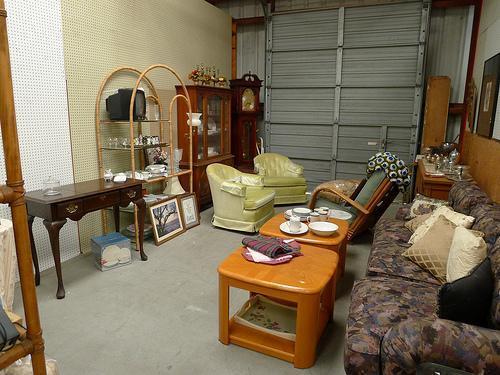How many chairs are seen?
Give a very brief answer. 3. How many couches are visible?
Give a very brief answer. 1. How many rectangular panels make up the metal door?
Give a very brief answer. 10. How many colors is the wall to the left?
Give a very brief answer. 2. 